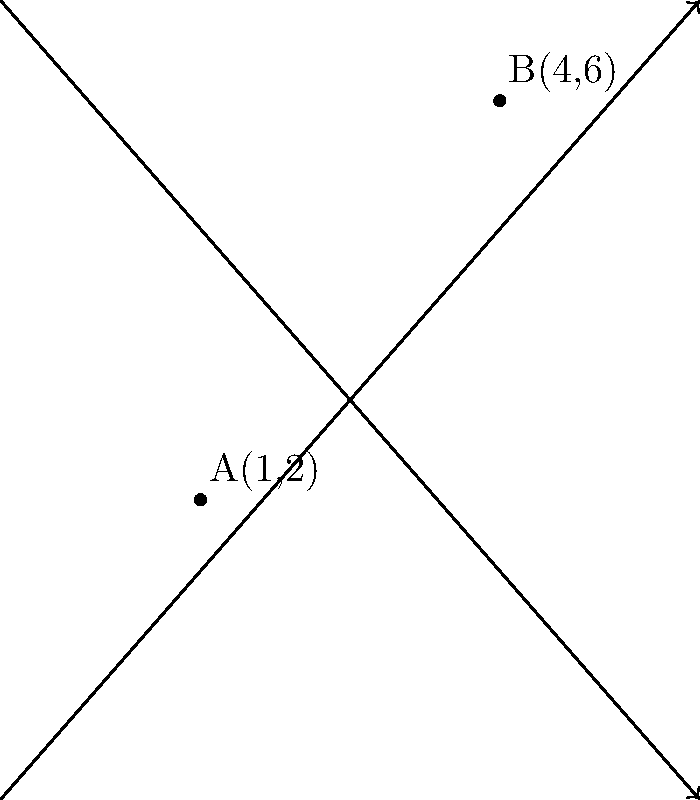In the sculpture garden of the Contemporary Art Museum, two avant-garde installations are placed at points A(1,2) and B(4,6) on a coordinate grid. As an aspiring art detective, you need to determine the precise distance between these two installations. Using the distance formula, calculate the distance between points A and B to the nearest tenth of a unit. To solve this puzzle, we'll use the distance formula derived from the Pythagorean theorem:

$$d = \sqrt{(x_2 - x_1)^2 + (y_2 - y_1)^2}$$

Where $(x_1, y_1)$ are the coordinates of point A, and $(x_2, y_2)$ are the coordinates of point B.

Step 1: Identify the coordinates
A(1,2): $x_1 = 1$, $y_1 = 2$
B(4,6): $x_2 = 4$, $y_2 = 6$

Step 2: Plug the values into the distance formula
$$d = \sqrt{(4 - 1)^2 + (6 - 2)^2}$$

Step 3: Simplify the expressions inside the parentheses
$$d = \sqrt{3^2 + 4^2}$$

Step 4: Calculate the squares
$$d = \sqrt{9 + 16}$$

Step 5: Add the values under the square root
$$d = \sqrt{25}$$

Step 6: Calculate the square root
$$d = 5$$

Therefore, the distance between the two art installations is 5 units.
Answer: 5 units 